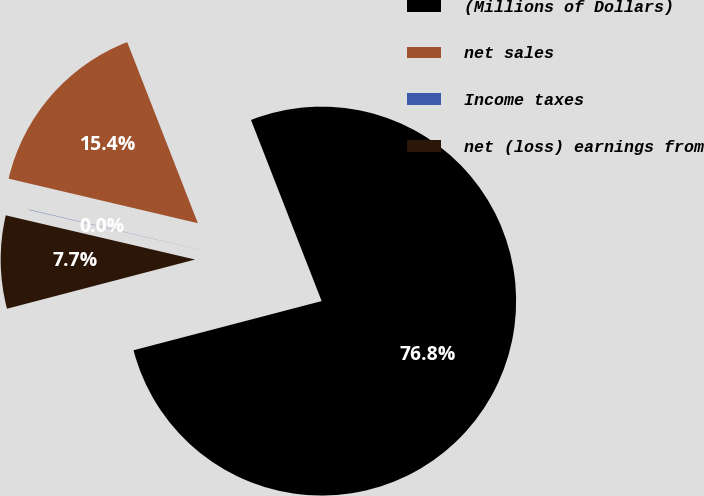<chart> <loc_0><loc_0><loc_500><loc_500><pie_chart><fcel>(Millions of Dollars)<fcel>net sales<fcel>Income taxes<fcel>net (loss) earnings from<nl><fcel>76.85%<fcel>15.4%<fcel>0.03%<fcel>7.72%<nl></chart> 